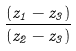<formula> <loc_0><loc_0><loc_500><loc_500>\frac { ( z _ { 1 } - z _ { 3 } ) } { ( z _ { 2 } - z _ { 3 } ) }</formula> 